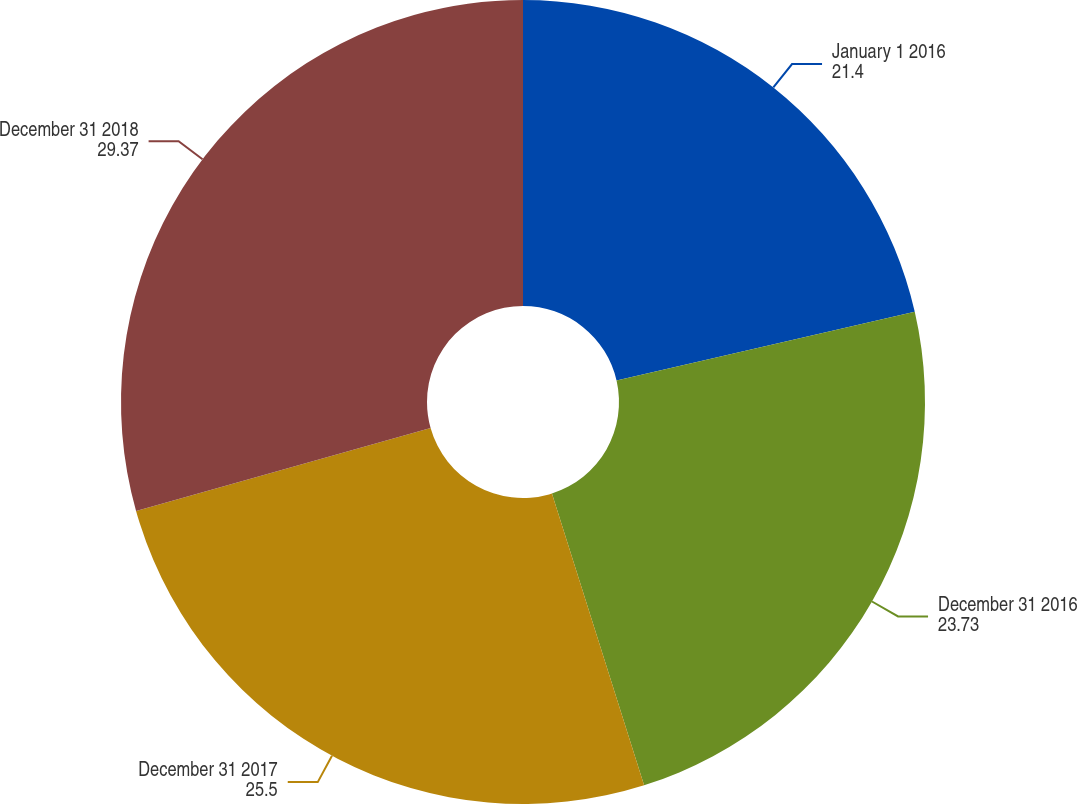Convert chart to OTSL. <chart><loc_0><loc_0><loc_500><loc_500><pie_chart><fcel>January 1 2016<fcel>December 31 2016<fcel>December 31 2017<fcel>December 31 2018<nl><fcel>21.4%<fcel>23.73%<fcel>25.5%<fcel>29.37%<nl></chart> 